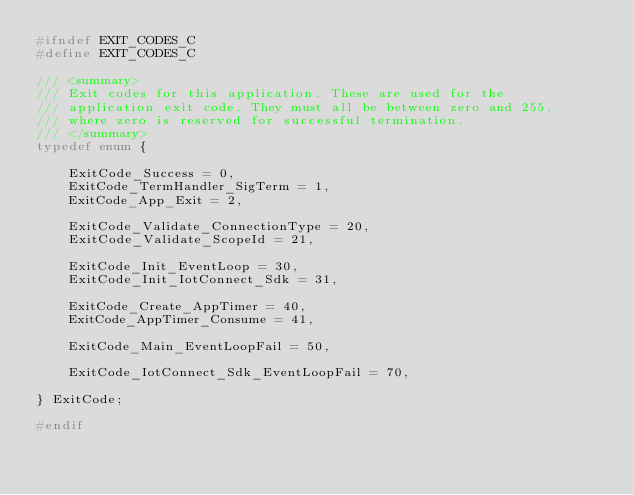Convert code to text. <code><loc_0><loc_0><loc_500><loc_500><_C_>#ifndef	EXIT_CODES_C
#define EXIT_CODES_C

/// <summary>
/// Exit codes for this application. These are used for the
/// application exit code. They must all be between zero and 255,
/// where zero is reserved for successful termination.
/// </summary>
typedef enum {

    ExitCode_Success = 0,
    ExitCode_TermHandler_SigTerm = 1,
    ExitCode_App_Exit = 2,

    ExitCode_Validate_ConnectionType = 20,
    ExitCode_Validate_ScopeId = 21,

    ExitCode_Init_EventLoop = 30,
    ExitCode_Init_IotConnect_Sdk = 31,

    ExitCode_Create_AppTimer = 40,
    ExitCode_AppTimer_Consume = 41,

    ExitCode_Main_EventLoopFail = 50,

    ExitCode_IotConnect_Sdk_EventLoopFail = 70,

} ExitCode;

#endif </code> 